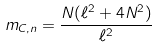Convert formula to latex. <formula><loc_0><loc_0><loc_500><loc_500>m _ { C , n } = \frac { N ( \ell ^ { 2 } + 4 N ^ { 2 } ) } { \ell ^ { 2 } }</formula> 